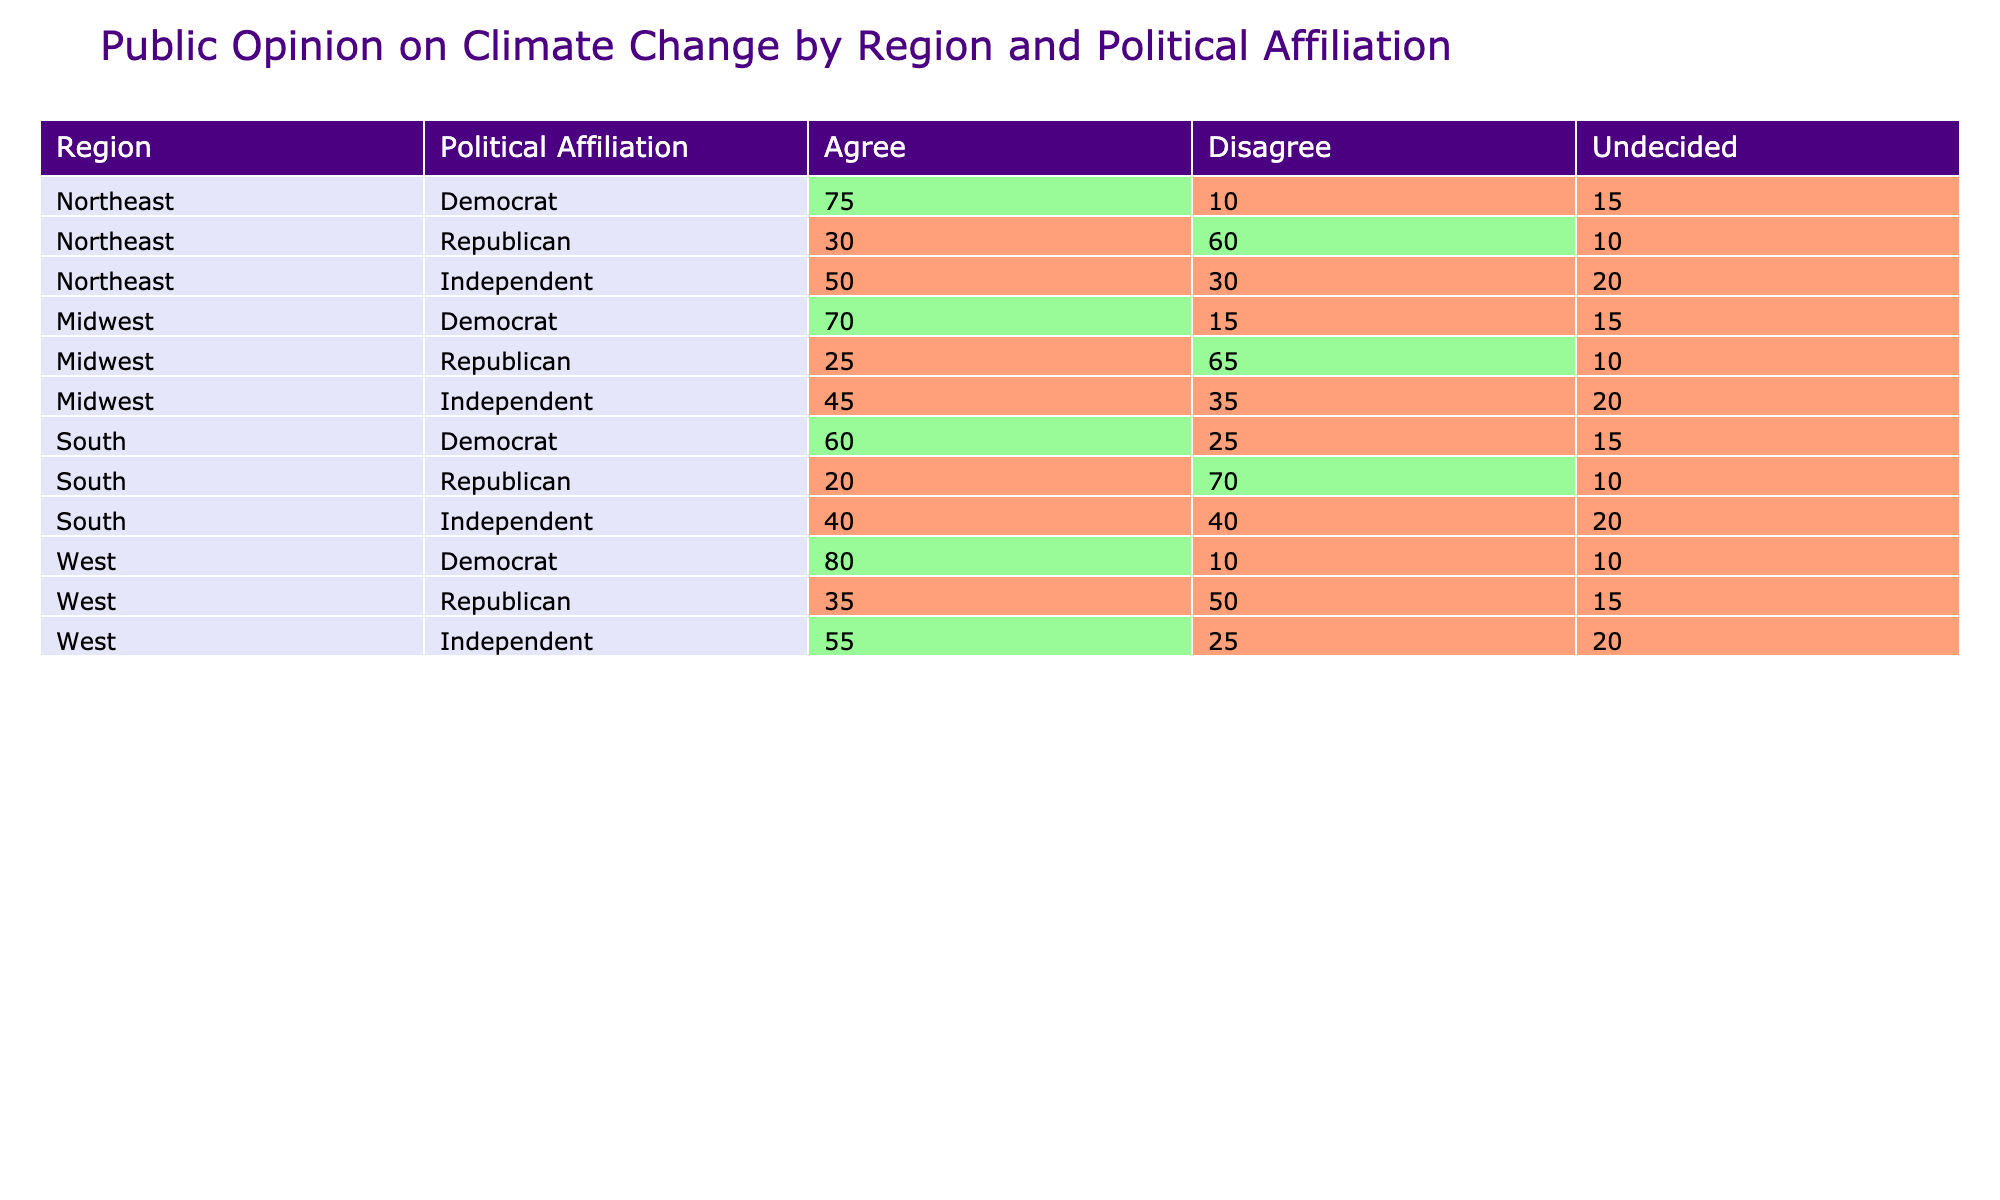What percentage of Northeast Independents agree with climate change? From the table, the percentage of Independents in the Northeast who agree with climate change is listed as 50.
Answer: 50 Which region has the highest percentage of Democrats agreeing with climate change? By comparing percentages from the table, the West has the highest percentage of Democrats agreeing with climate change at 80.
Answer: 80 What is the total percentage of Midwest Republicans who either disagree or are undecided about climate change? Midwest Republicans have 65% who disagree and 10% who are undecided. Summing these gives 65 + 10 = 75.
Answer: 75 Is it true that more than 50% of South Democrats agree with climate change? The data shows that 60% of South Democrats agree with climate change, which is indeed more than 50%.
Answer: Yes What is the difference in agreement with climate change between Northeast Republicans and West Republicans? Northeast Republicans have 30% agreeing, while West Republicans have 35%. The difference is 35 - 30 = 5 percentage points.
Answer: 5 How many total Independents across all regions are undecided about climate change? For Independents: Northeast has 20, Midwest has 20, South has 20, and West has 20. Summing these gives 20 + 20 + 20 + 20 = 80.
Answer: 80 Are there more Midwest Democrats who agree with climate change than South Independents? Midwest Democrats agree at 70%, while South Independents agree at 40%. Since 70 is greater than 40, the statement is true.
Answer: Yes What percentage of South Republicans agree with climate change? The table shows that South Republicans agree with climate change at 20%.
Answer: 20 